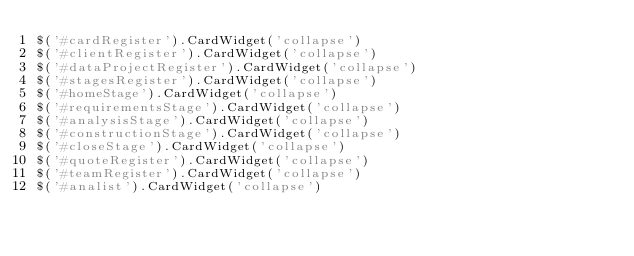<code> <loc_0><loc_0><loc_500><loc_500><_JavaScript_>$('#cardRegister').CardWidget('collapse')
$('#clientRegister').CardWidget('collapse')
$('#dataProjectRegister').CardWidget('collapse')
$('#stagesRegister').CardWidget('collapse')
$('#homeStage').CardWidget('collapse')
$('#requirementsStage').CardWidget('collapse')
$('#analysisStage').CardWidget('collapse')
$('#constructionStage').CardWidget('collapse')
$('#closeStage').CardWidget('collapse')
$('#quoteRegister').CardWidget('collapse')
$('#teamRegister').CardWidget('collapse')
$('#analist').CardWidget('collapse')







</code> 